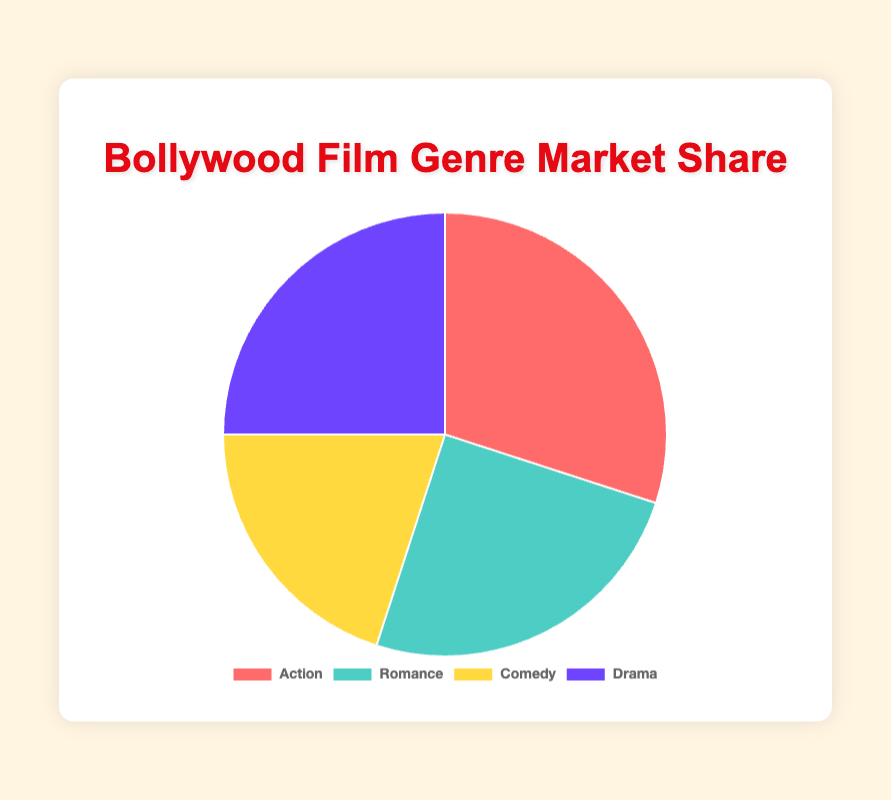What percentage of the market share does the Comedy genre hold? Referring to the pie chart, the Comedy genre is shown to have a market share of 20%.
Answer: 20% Which genre has the largest market share? Observing the pie chart, the Action genre dominates the market share with 30%.
Answer: Action What is the combined market share of Romance and Drama genres? Adding the market share percentages of Romance (25%) and Drama (25%) gives us a combined market share of 50%.
Answer: 50% Which two genres have an equal market share? From the pie chart, both Romance and Drama genres have an equal market share of 25%.
Answer: Romance and Drama How does the market share of Action compare to that of Comedy? The Action genre has a market share of 30%, which is higher than Comedy's 20%.
Answer: Action has a higher market share than Comedy What color represents the Romance genre in the chart? According to the pie chart legend, the color representing the Romance genre is teal.
Answer: Teal If the total market share is 100%, what is the market share difference between Action and Drama genres? The market share of Action is 30% and Drama is 25%. Subtracting these values gives us a difference of 5%.
Answer: 5% What does the largest segment in the pie chart represent? Observing the pie chart, the largest segment represents the Action genre with 30%.
Answer: Action How many genres have a market share percentage higher than 20%? From the pie chart, three genres (Action, Romance, Drama) each have market shares greater than 20%.
Answer: 3 Is the market share of Drama greater than Comedy? Comparing the pie chart's segments, Drama has a market share of 25%, which is greater than Comedy's 20%.
Answer: Yes 